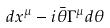<formula> <loc_0><loc_0><loc_500><loc_500>d x ^ { \mu } - i \bar { \theta } \Gamma ^ { \mu } d \theta</formula> 